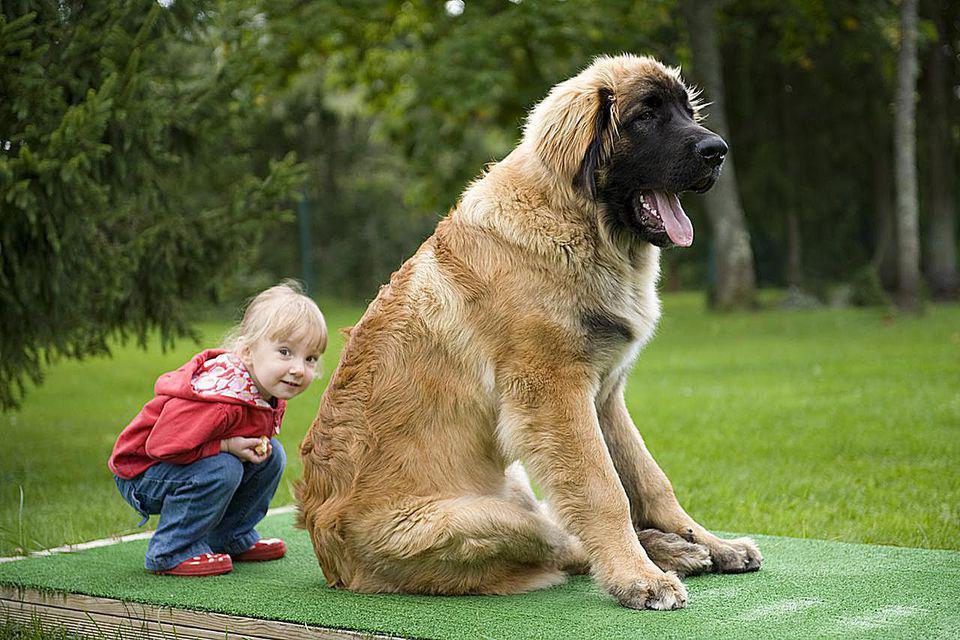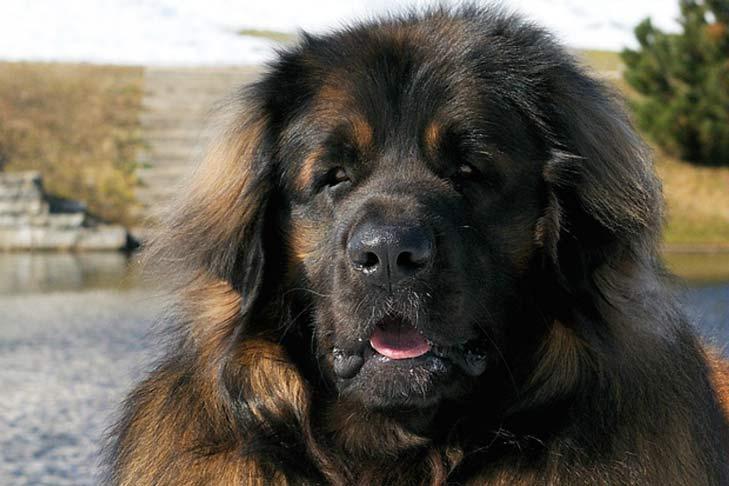The first image is the image on the left, the second image is the image on the right. For the images shown, is this caption "A female with bent knees is on the left of a big dog, which is the only dog in the image." true? Answer yes or no. Yes. The first image is the image on the left, the second image is the image on the right. Assess this claim about the two images: "The left image contains exactly two dogs.". Correct or not? Answer yes or no. No. 